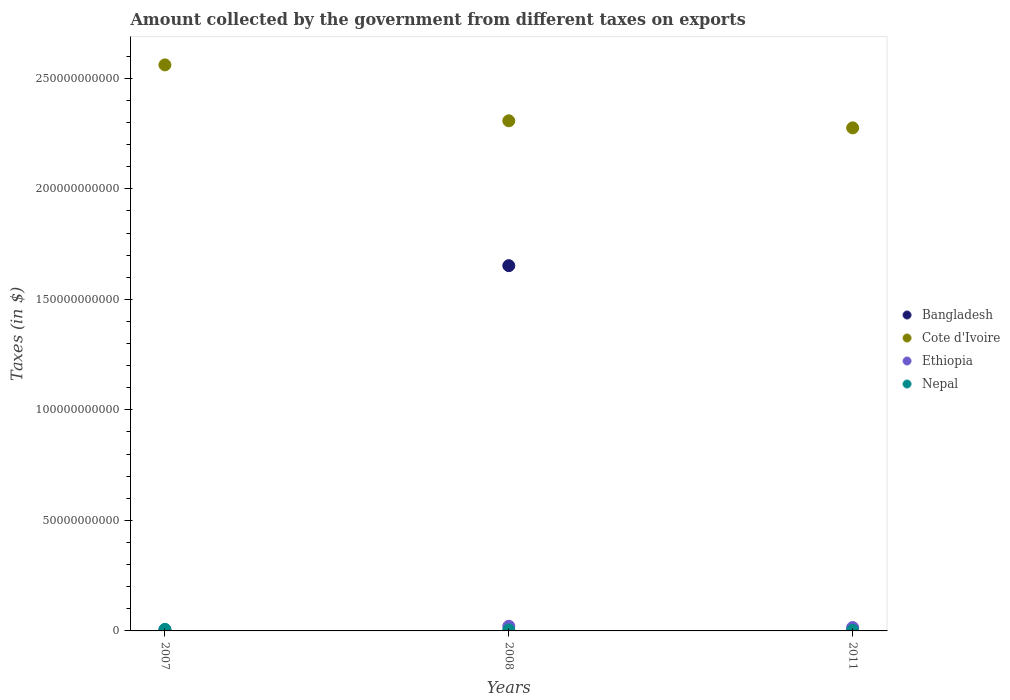How many different coloured dotlines are there?
Make the answer very short. 4. What is the amount collected by the government from taxes on exports in Nepal in 2008?
Keep it short and to the point. 4.46e+08. Across all years, what is the maximum amount collected by the government from taxes on exports in Bangladesh?
Your answer should be compact. 1.65e+11. Across all years, what is the minimum amount collected by the government from taxes on exports in Ethiopia?
Provide a short and direct response. 4.93e+08. In which year was the amount collected by the government from taxes on exports in Nepal minimum?
Make the answer very short. 2011. What is the total amount collected by the government from taxes on exports in Cote d'Ivoire in the graph?
Offer a terse response. 7.14e+11. What is the difference between the amount collected by the government from taxes on exports in Nepal in 2008 and that in 2011?
Your response must be concise. 1.53e+08. What is the difference between the amount collected by the government from taxes on exports in Cote d'Ivoire in 2008 and the amount collected by the government from taxes on exports in Ethiopia in 2007?
Keep it short and to the point. 2.30e+11. What is the average amount collected by the government from taxes on exports in Bangladesh per year?
Your answer should be compact. 5.51e+1. In the year 2011, what is the difference between the amount collected by the government from taxes on exports in Cote d'Ivoire and amount collected by the government from taxes on exports in Ethiopia?
Your answer should be compact. 2.26e+11. In how many years, is the amount collected by the government from taxes on exports in Bangladesh greater than 50000000000 $?
Provide a short and direct response. 1. What is the ratio of the amount collected by the government from taxes on exports in Cote d'Ivoire in 2007 to that in 2011?
Provide a succinct answer. 1.13. Is the amount collected by the government from taxes on exports in Cote d'Ivoire in 2007 less than that in 2011?
Keep it short and to the point. No. What is the difference between the highest and the second highest amount collected by the government from taxes on exports in Bangladesh?
Your response must be concise. 1.65e+11. What is the difference between the highest and the lowest amount collected by the government from taxes on exports in Nepal?
Make the answer very short. 4.06e+08. In how many years, is the amount collected by the government from taxes on exports in Cote d'Ivoire greater than the average amount collected by the government from taxes on exports in Cote d'Ivoire taken over all years?
Your answer should be very brief. 1. Is the sum of the amount collected by the government from taxes on exports in Nepal in 2007 and 2008 greater than the maximum amount collected by the government from taxes on exports in Cote d'Ivoire across all years?
Make the answer very short. No. Does the amount collected by the government from taxes on exports in Ethiopia monotonically increase over the years?
Offer a very short reply. No. Is the amount collected by the government from taxes on exports in Cote d'Ivoire strictly less than the amount collected by the government from taxes on exports in Nepal over the years?
Keep it short and to the point. No. How many years are there in the graph?
Keep it short and to the point. 3. What is the difference between two consecutive major ticks on the Y-axis?
Make the answer very short. 5.00e+1. Are the values on the major ticks of Y-axis written in scientific E-notation?
Your answer should be compact. No. Does the graph contain any zero values?
Make the answer very short. No. Does the graph contain grids?
Offer a terse response. No. Where does the legend appear in the graph?
Provide a short and direct response. Center right. How many legend labels are there?
Provide a short and direct response. 4. How are the legend labels stacked?
Provide a short and direct response. Vertical. What is the title of the graph?
Give a very brief answer. Amount collected by the government from different taxes on exports. Does "Virgin Islands" appear as one of the legend labels in the graph?
Provide a succinct answer. No. What is the label or title of the Y-axis?
Ensure brevity in your answer.  Taxes (in $). What is the Taxes (in $) of Bangladesh in 2007?
Your answer should be very brief. 3.38e+05. What is the Taxes (in $) of Cote d'Ivoire in 2007?
Give a very brief answer. 2.56e+11. What is the Taxes (in $) in Ethiopia in 2007?
Your response must be concise. 4.93e+08. What is the Taxes (in $) in Nepal in 2007?
Offer a very short reply. 6.99e+08. What is the Taxes (in $) in Bangladesh in 2008?
Make the answer very short. 1.65e+11. What is the Taxes (in $) of Cote d'Ivoire in 2008?
Your answer should be very brief. 2.31e+11. What is the Taxes (in $) of Ethiopia in 2008?
Provide a short and direct response. 2.11e+09. What is the Taxes (in $) in Nepal in 2008?
Your answer should be compact. 4.46e+08. What is the Taxes (in $) of Bangladesh in 2011?
Ensure brevity in your answer.  8000. What is the Taxes (in $) of Cote d'Ivoire in 2011?
Your answer should be very brief. 2.28e+11. What is the Taxes (in $) in Ethiopia in 2011?
Ensure brevity in your answer.  1.53e+09. What is the Taxes (in $) of Nepal in 2011?
Your response must be concise. 2.92e+08. Across all years, what is the maximum Taxes (in $) in Bangladesh?
Provide a succinct answer. 1.65e+11. Across all years, what is the maximum Taxes (in $) in Cote d'Ivoire?
Make the answer very short. 2.56e+11. Across all years, what is the maximum Taxes (in $) in Ethiopia?
Keep it short and to the point. 2.11e+09. Across all years, what is the maximum Taxes (in $) in Nepal?
Offer a terse response. 6.99e+08. Across all years, what is the minimum Taxes (in $) of Bangladesh?
Your answer should be very brief. 8000. Across all years, what is the minimum Taxes (in $) in Cote d'Ivoire?
Offer a terse response. 2.28e+11. Across all years, what is the minimum Taxes (in $) in Ethiopia?
Offer a very short reply. 4.93e+08. Across all years, what is the minimum Taxes (in $) of Nepal?
Your answer should be compact. 2.92e+08. What is the total Taxes (in $) in Bangladesh in the graph?
Ensure brevity in your answer.  1.65e+11. What is the total Taxes (in $) of Cote d'Ivoire in the graph?
Keep it short and to the point. 7.14e+11. What is the total Taxes (in $) of Ethiopia in the graph?
Provide a succinct answer. 4.14e+09. What is the total Taxes (in $) of Nepal in the graph?
Ensure brevity in your answer.  1.44e+09. What is the difference between the Taxes (in $) of Bangladesh in 2007 and that in 2008?
Offer a very short reply. -1.65e+11. What is the difference between the Taxes (in $) of Cote d'Ivoire in 2007 and that in 2008?
Give a very brief answer. 2.53e+1. What is the difference between the Taxes (in $) of Ethiopia in 2007 and that in 2008?
Make the answer very short. -1.62e+09. What is the difference between the Taxes (in $) of Nepal in 2007 and that in 2008?
Your answer should be compact. 2.53e+08. What is the difference between the Taxes (in $) in Cote d'Ivoire in 2007 and that in 2011?
Keep it short and to the point. 2.85e+1. What is the difference between the Taxes (in $) of Ethiopia in 2007 and that in 2011?
Offer a terse response. -1.04e+09. What is the difference between the Taxes (in $) in Nepal in 2007 and that in 2011?
Your answer should be very brief. 4.06e+08. What is the difference between the Taxes (in $) in Bangladesh in 2008 and that in 2011?
Provide a succinct answer. 1.65e+11. What is the difference between the Taxes (in $) of Cote d'Ivoire in 2008 and that in 2011?
Offer a very short reply. 3.20e+09. What is the difference between the Taxes (in $) of Ethiopia in 2008 and that in 2011?
Provide a short and direct response. 5.79e+08. What is the difference between the Taxes (in $) in Nepal in 2008 and that in 2011?
Offer a very short reply. 1.53e+08. What is the difference between the Taxes (in $) of Bangladesh in 2007 and the Taxes (in $) of Cote d'Ivoire in 2008?
Give a very brief answer. -2.31e+11. What is the difference between the Taxes (in $) of Bangladesh in 2007 and the Taxes (in $) of Ethiopia in 2008?
Offer a terse response. -2.11e+09. What is the difference between the Taxes (in $) of Bangladesh in 2007 and the Taxes (in $) of Nepal in 2008?
Give a very brief answer. -4.45e+08. What is the difference between the Taxes (in $) in Cote d'Ivoire in 2007 and the Taxes (in $) in Ethiopia in 2008?
Make the answer very short. 2.54e+11. What is the difference between the Taxes (in $) in Cote d'Ivoire in 2007 and the Taxes (in $) in Nepal in 2008?
Offer a terse response. 2.56e+11. What is the difference between the Taxes (in $) in Ethiopia in 2007 and the Taxes (in $) in Nepal in 2008?
Provide a succinct answer. 4.75e+07. What is the difference between the Taxes (in $) in Bangladesh in 2007 and the Taxes (in $) in Cote d'Ivoire in 2011?
Offer a terse response. -2.28e+11. What is the difference between the Taxes (in $) of Bangladesh in 2007 and the Taxes (in $) of Ethiopia in 2011?
Your response must be concise. -1.53e+09. What is the difference between the Taxes (in $) in Bangladesh in 2007 and the Taxes (in $) in Nepal in 2011?
Your answer should be very brief. -2.92e+08. What is the difference between the Taxes (in $) in Cote d'Ivoire in 2007 and the Taxes (in $) in Ethiopia in 2011?
Offer a very short reply. 2.55e+11. What is the difference between the Taxes (in $) of Cote d'Ivoire in 2007 and the Taxes (in $) of Nepal in 2011?
Your response must be concise. 2.56e+11. What is the difference between the Taxes (in $) of Ethiopia in 2007 and the Taxes (in $) of Nepal in 2011?
Give a very brief answer. 2.01e+08. What is the difference between the Taxes (in $) in Bangladesh in 2008 and the Taxes (in $) in Cote d'Ivoire in 2011?
Your response must be concise. -6.23e+1. What is the difference between the Taxes (in $) in Bangladesh in 2008 and the Taxes (in $) in Ethiopia in 2011?
Provide a succinct answer. 1.64e+11. What is the difference between the Taxes (in $) in Bangladesh in 2008 and the Taxes (in $) in Nepal in 2011?
Your response must be concise. 1.65e+11. What is the difference between the Taxes (in $) of Cote d'Ivoire in 2008 and the Taxes (in $) of Ethiopia in 2011?
Your answer should be compact. 2.29e+11. What is the difference between the Taxes (in $) in Cote d'Ivoire in 2008 and the Taxes (in $) in Nepal in 2011?
Your answer should be compact. 2.31e+11. What is the difference between the Taxes (in $) of Ethiopia in 2008 and the Taxes (in $) of Nepal in 2011?
Keep it short and to the point. 1.82e+09. What is the average Taxes (in $) in Bangladesh per year?
Provide a succinct answer. 5.51e+1. What is the average Taxes (in $) in Cote d'Ivoire per year?
Give a very brief answer. 2.38e+11. What is the average Taxes (in $) in Ethiopia per year?
Offer a terse response. 1.38e+09. What is the average Taxes (in $) of Nepal per year?
Ensure brevity in your answer.  4.79e+08. In the year 2007, what is the difference between the Taxes (in $) of Bangladesh and Taxes (in $) of Cote d'Ivoire?
Your answer should be compact. -2.56e+11. In the year 2007, what is the difference between the Taxes (in $) in Bangladesh and Taxes (in $) in Ethiopia?
Ensure brevity in your answer.  -4.93e+08. In the year 2007, what is the difference between the Taxes (in $) of Bangladesh and Taxes (in $) of Nepal?
Your answer should be very brief. -6.98e+08. In the year 2007, what is the difference between the Taxes (in $) in Cote d'Ivoire and Taxes (in $) in Ethiopia?
Keep it short and to the point. 2.56e+11. In the year 2007, what is the difference between the Taxes (in $) of Cote d'Ivoire and Taxes (in $) of Nepal?
Ensure brevity in your answer.  2.55e+11. In the year 2007, what is the difference between the Taxes (in $) of Ethiopia and Taxes (in $) of Nepal?
Your answer should be compact. -2.06e+08. In the year 2008, what is the difference between the Taxes (in $) of Bangladesh and Taxes (in $) of Cote d'Ivoire?
Your answer should be compact. -6.55e+1. In the year 2008, what is the difference between the Taxes (in $) of Bangladesh and Taxes (in $) of Ethiopia?
Offer a terse response. 1.63e+11. In the year 2008, what is the difference between the Taxes (in $) of Bangladesh and Taxes (in $) of Nepal?
Provide a short and direct response. 1.65e+11. In the year 2008, what is the difference between the Taxes (in $) in Cote d'Ivoire and Taxes (in $) in Ethiopia?
Offer a terse response. 2.29e+11. In the year 2008, what is the difference between the Taxes (in $) in Cote d'Ivoire and Taxes (in $) in Nepal?
Ensure brevity in your answer.  2.30e+11. In the year 2008, what is the difference between the Taxes (in $) of Ethiopia and Taxes (in $) of Nepal?
Offer a very short reply. 1.67e+09. In the year 2011, what is the difference between the Taxes (in $) of Bangladesh and Taxes (in $) of Cote d'Ivoire?
Your response must be concise. -2.28e+11. In the year 2011, what is the difference between the Taxes (in $) in Bangladesh and Taxes (in $) in Ethiopia?
Your response must be concise. -1.53e+09. In the year 2011, what is the difference between the Taxes (in $) in Bangladesh and Taxes (in $) in Nepal?
Keep it short and to the point. -2.92e+08. In the year 2011, what is the difference between the Taxes (in $) in Cote d'Ivoire and Taxes (in $) in Ethiopia?
Offer a terse response. 2.26e+11. In the year 2011, what is the difference between the Taxes (in $) in Cote d'Ivoire and Taxes (in $) in Nepal?
Offer a very short reply. 2.27e+11. In the year 2011, what is the difference between the Taxes (in $) of Ethiopia and Taxes (in $) of Nepal?
Offer a very short reply. 1.24e+09. What is the ratio of the Taxes (in $) of Cote d'Ivoire in 2007 to that in 2008?
Your response must be concise. 1.11. What is the ratio of the Taxes (in $) of Ethiopia in 2007 to that in 2008?
Your response must be concise. 0.23. What is the ratio of the Taxes (in $) in Nepal in 2007 to that in 2008?
Offer a very short reply. 1.57. What is the ratio of the Taxes (in $) in Bangladesh in 2007 to that in 2011?
Provide a short and direct response. 42.25. What is the ratio of the Taxes (in $) of Cote d'Ivoire in 2007 to that in 2011?
Offer a terse response. 1.13. What is the ratio of the Taxes (in $) in Ethiopia in 2007 to that in 2011?
Provide a short and direct response. 0.32. What is the ratio of the Taxes (in $) in Nepal in 2007 to that in 2011?
Keep it short and to the point. 2.39. What is the ratio of the Taxes (in $) of Bangladesh in 2008 to that in 2011?
Provide a short and direct response. 2.07e+07. What is the ratio of the Taxes (in $) of Cote d'Ivoire in 2008 to that in 2011?
Ensure brevity in your answer.  1.01. What is the ratio of the Taxes (in $) of Ethiopia in 2008 to that in 2011?
Make the answer very short. 1.38. What is the ratio of the Taxes (in $) of Nepal in 2008 to that in 2011?
Provide a short and direct response. 1.52. What is the difference between the highest and the second highest Taxes (in $) in Bangladesh?
Provide a short and direct response. 1.65e+11. What is the difference between the highest and the second highest Taxes (in $) of Cote d'Ivoire?
Your answer should be very brief. 2.53e+1. What is the difference between the highest and the second highest Taxes (in $) of Ethiopia?
Provide a short and direct response. 5.79e+08. What is the difference between the highest and the second highest Taxes (in $) of Nepal?
Make the answer very short. 2.53e+08. What is the difference between the highest and the lowest Taxes (in $) in Bangladesh?
Offer a very short reply. 1.65e+11. What is the difference between the highest and the lowest Taxes (in $) of Cote d'Ivoire?
Offer a terse response. 2.85e+1. What is the difference between the highest and the lowest Taxes (in $) of Ethiopia?
Your answer should be very brief. 1.62e+09. What is the difference between the highest and the lowest Taxes (in $) in Nepal?
Keep it short and to the point. 4.06e+08. 